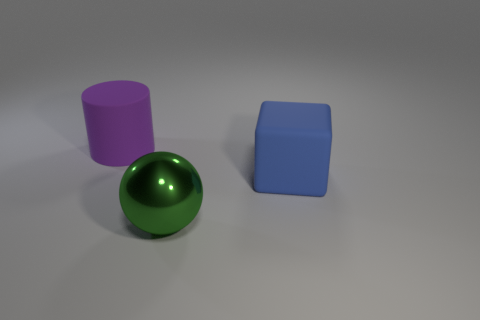What size is the sphere?
Give a very brief answer. Large. Is there a green thing that is to the right of the matte object right of the matte thing to the left of the blue rubber cube?
Give a very brief answer. No. There is a blue block; how many large matte cubes are behind it?
Your answer should be compact. 0. How many objects are big objects that are behind the large blue thing or large matte things that are right of the green metal thing?
Make the answer very short. 2. Is the number of green shiny spheres greater than the number of small yellow metal blocks?
Ensure brevity in your answer.  Yes. What color is the matte thing that is on the right side of the big purple rubber cylinder?
Your answer should be very brief. Blue. Does the purple matte object have the same shape as the big green thing?
Give a very brief answer. No. The thing that is left of the big matte cube and right of the purple matte thing is what color?
Keep it short and to the point. Green. Does the matte object that is in front of the big purple matte thing have the same size as the matte thing that is behind the blue matte thing?
Offer a terse response. Yes. What number of things are large rubber things that are on the left side of the big metal sphere or big green shiny objects?
Give a very brief answer. 2. 